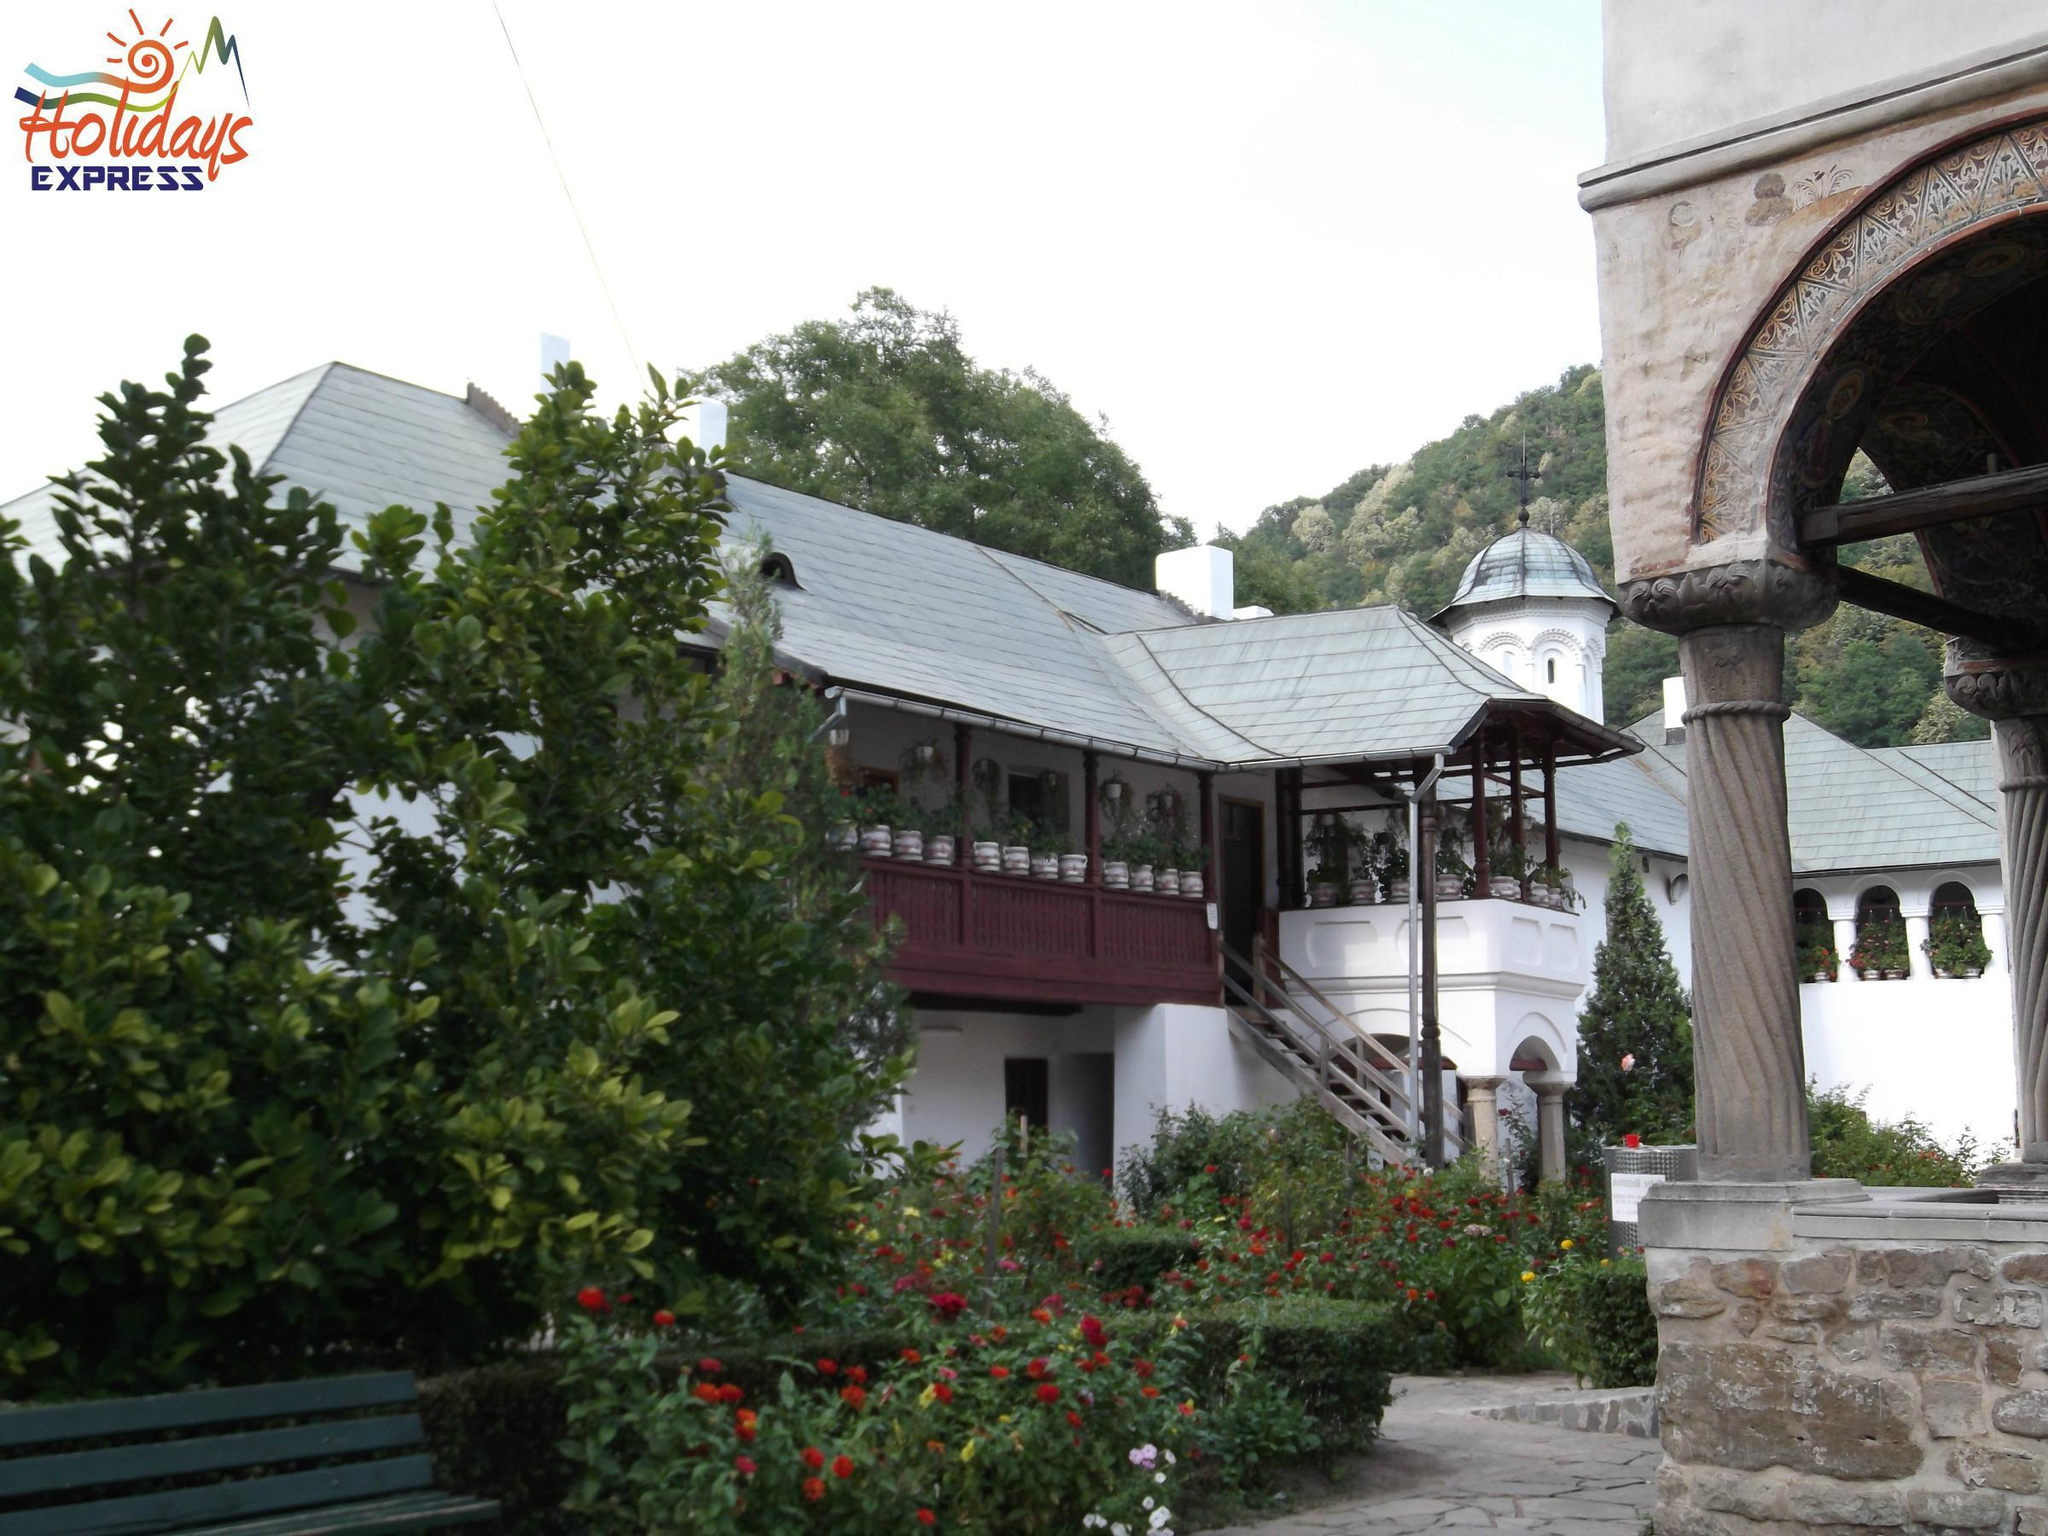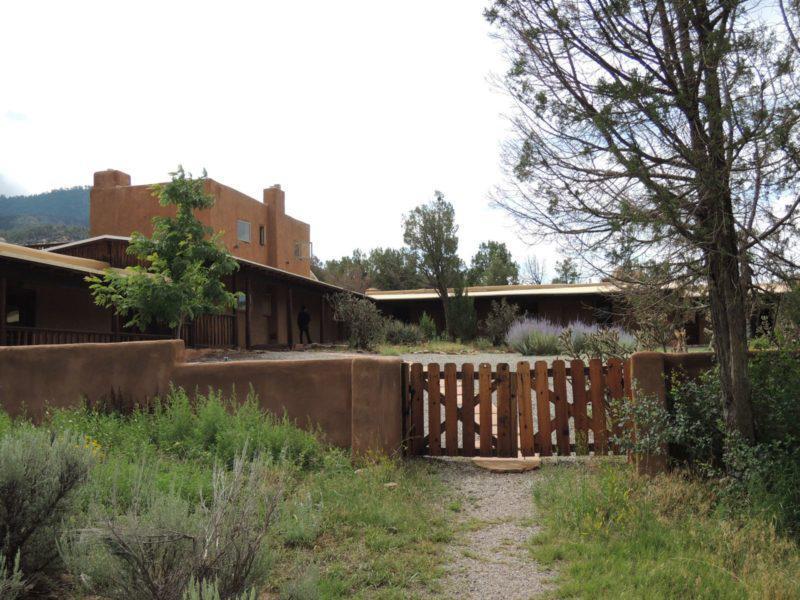The first image is the image on the left, the second image is the image on the right. Assess this claim about the two images: "At least one image shows a seating area along a row of archways that overlooks a garden area.". Correct or not? Answer yes or no. No. 